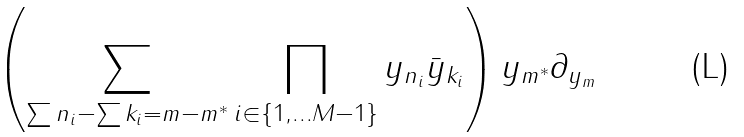Convert formula to latex. <formula><loc_0><loc_0><loc_500><loc_500>\left ( \sum _ { \sum n _ { i } - \sum k _ { i } = m - m ^ { * } } \prod _ { i \in \{ 1 , \dots M - 1 \} } y _ { n _ { i } } \bar { y } _ { k _ { i } } \right ) y _ { m ^ { * } } \partial _ { y _ { m } }</formula> 